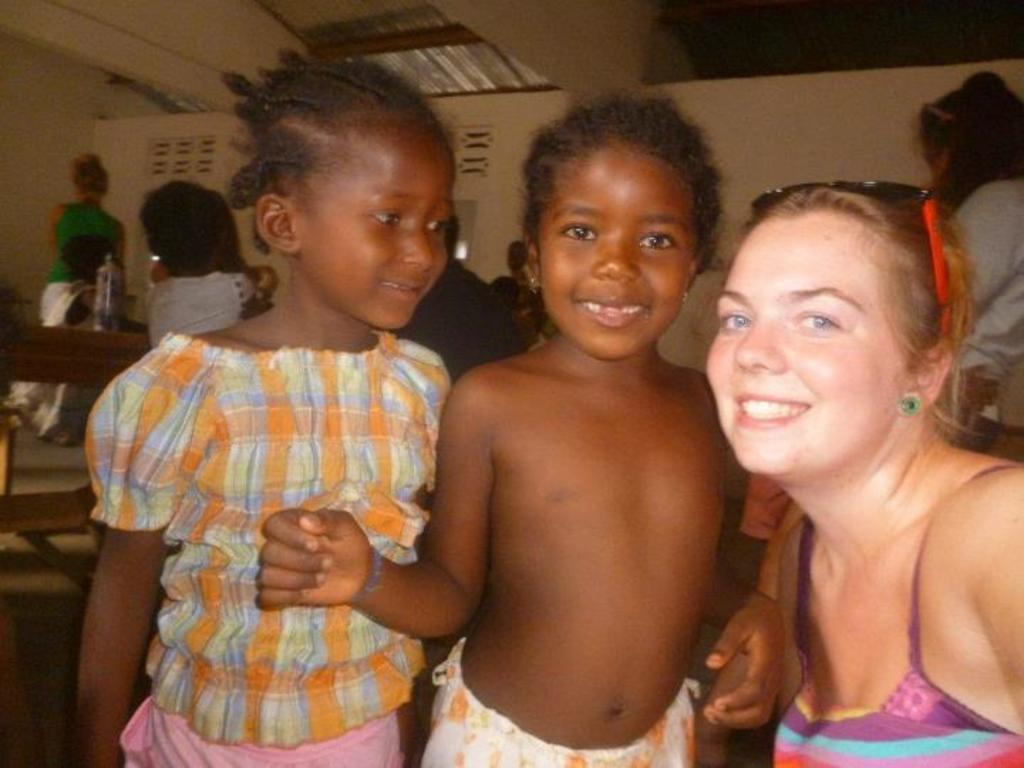How many people are present in the image? There are three people in the image. What is the facial expression of the people in the image? The three people are smiling. Can you describe the background of the image? There are people visible in the background of the image, and there is a wall in the background as well. What type of locket is being touched by one of the people in the image? There is no locket present in the image, and no one is touching any object. 